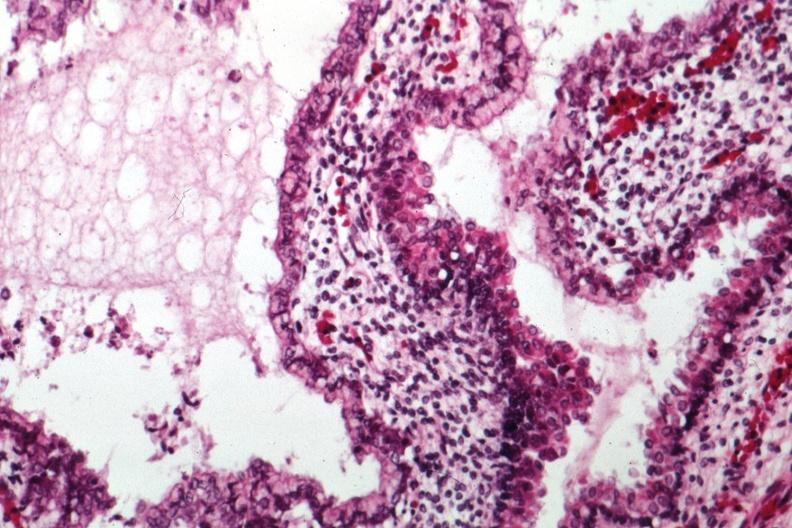does this image show epithelial component like intestine?
Answer the question using a single word or phrase. Yes 